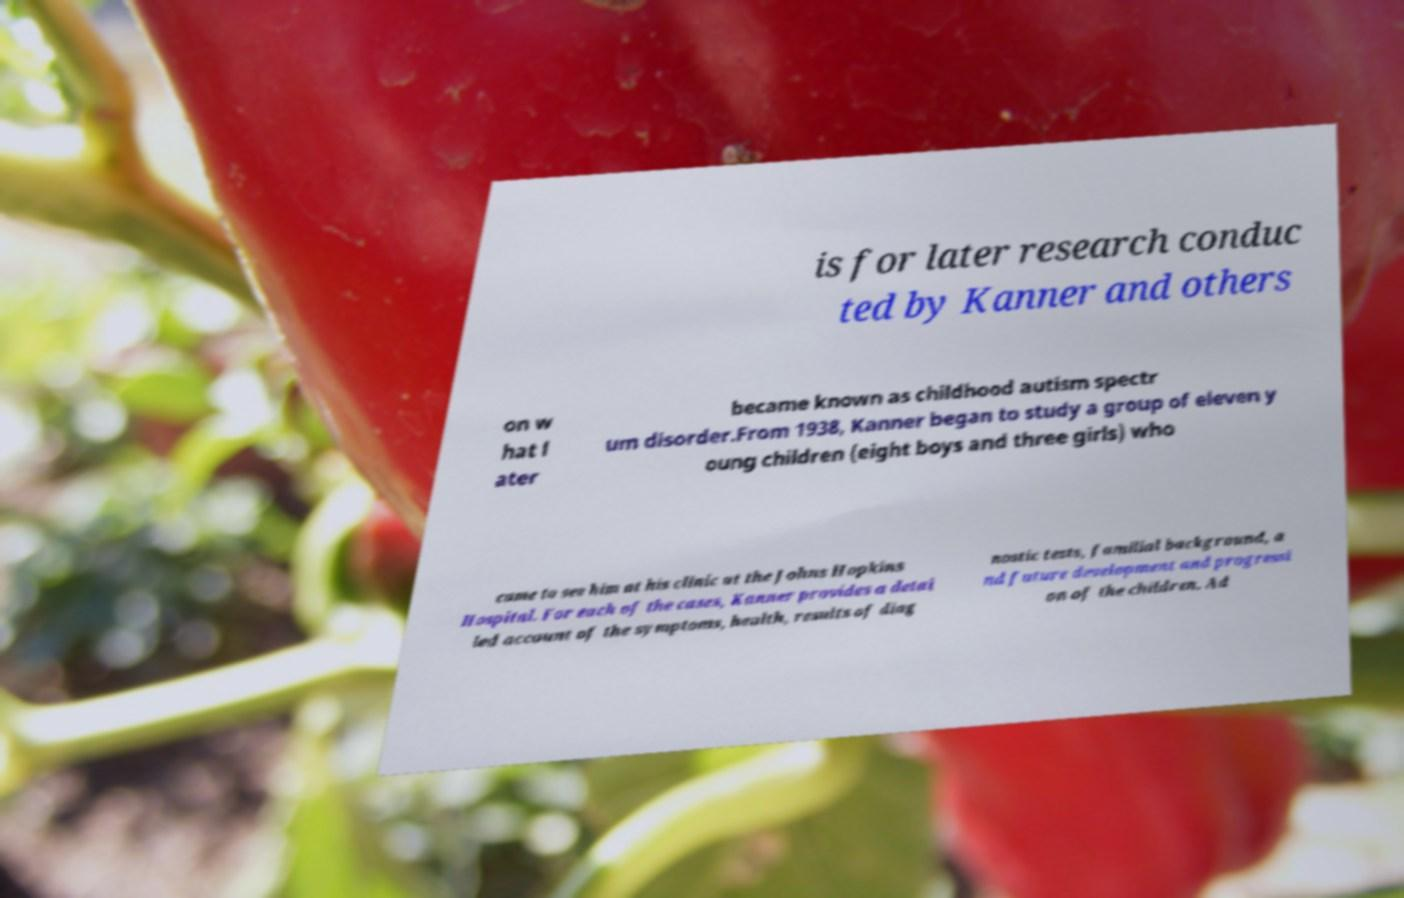Can you accurately transcribe the text from the provided image for me? is for later research conduc ted by Kanner and others on w hat l ater became known as childhood autism spectr um disorder.From 1938, Kanner began to study a group of eleven y oung children (eight boys and three girls) who came to see him at his clinic at the Johns Hopkins Hospital. For each of the cases, Kanner provides a detai led account of the symptoms, health, results of diag nostic tests, familial background, a nd future development and progressi on of the children. Ad 